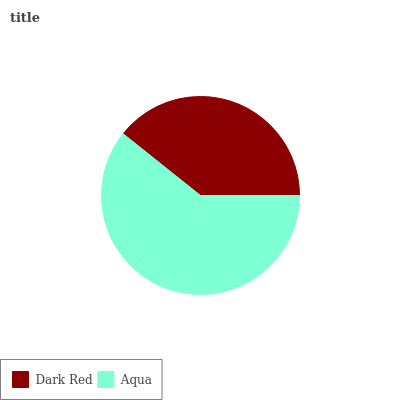Is Dark Red the minimum?
Answer yes or no. Yes. Is Aqua the maximum?
Answer yes or no. Yes. Is Aqua the minimum?
Answer yes or no. No. Is Aqua greater than Dark Red?
Answer yes or no. Yes. Is Dark Red less than Aqua?
Answer yes or no. Yes. Is Dark Red greater than Aqua?
Answer yes or no. No. Is Aqua less than Dark Red?
Answer yes or no. No. Is Aqua the high median?
Answer yes or no. Yes. Is Dark Red the low median?
Answer yes or no. Yes. Is Dark Red the high median?
Answer yes or no. No. Is Aqua the low median?
Answer yes or no. No. 